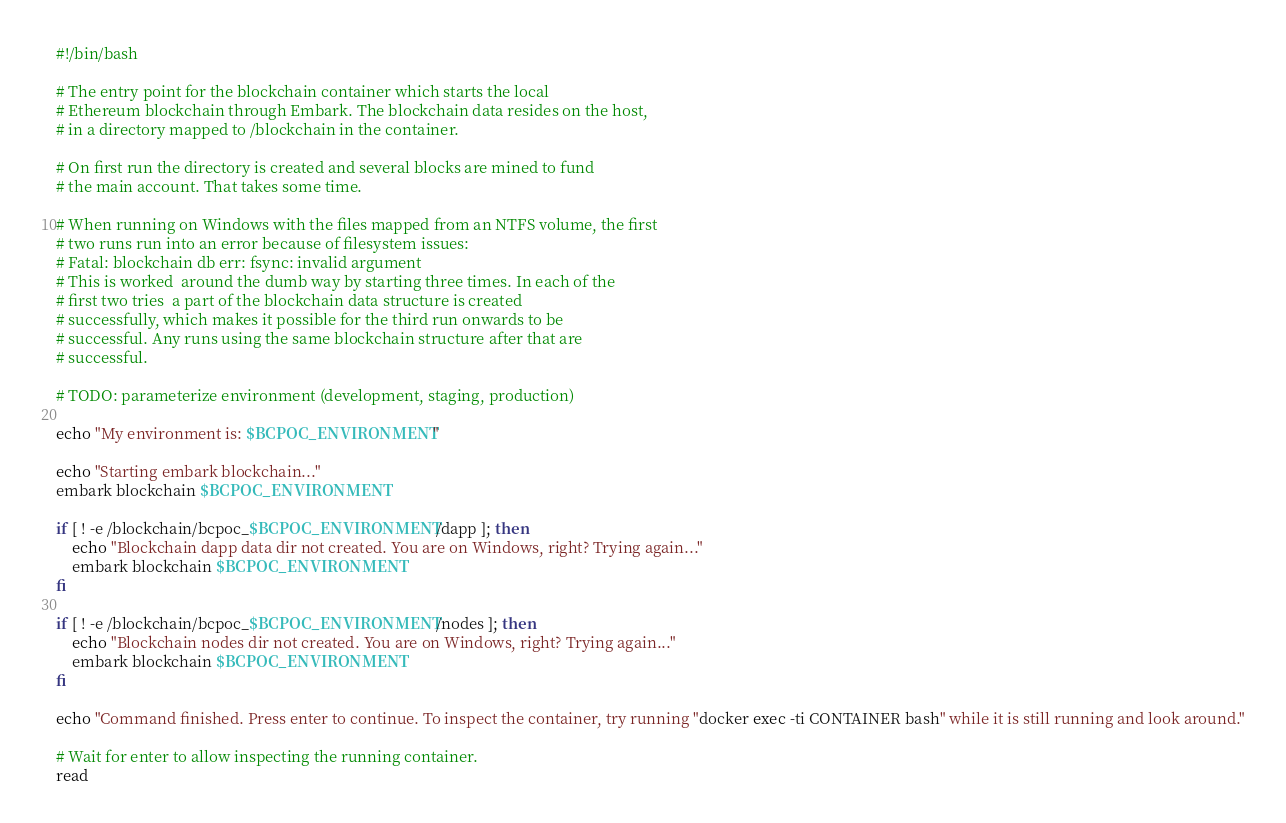Convert code to text. <code><loc_0><loc_0><loc_500><loc_500><_Bash_>#!/bin/bash

# The entry point for the blockchain container which starts the local
# Ethereum blockchain through Embark. The blockchain data resides on the host,
# in a directory mapped to /blockchain in the container.

# On first run the directory is created and several blocks are mined to fund
# the main account. That takes some time.

# When running on Windows with the files mapped from an NTFS volume, the first
# two runs run into an error because of filesystem issues:
# Fatal: blockchain db err: fsync: invalid argument
# This is worked  around the dumb way by starting three times. In each of the
# first two tries  a part of the blockchain data structure is created
# successfully, which makes it possible for the third run onwards to be
# successful. Any runs using the same blockchain structure after that are
# successful.

# TODO: parameterize environment (development, staging, production)

echo "My environment is: $BCPOC_ENVIRONMENT"

echo "Starting embark blockchain..."
embark blockchain $BCPOC_ENVIRONMENT

if [ ! -e /blockchain/bcpoc_$BCPOC_ENVIRONMENT/dapp ]; then
    echo "Blockchain dapp data dir not created. You are on Windows, right? Trying again..."
    embark blockchain $BCPOC_ENVIRONMENT
fi

if [ ! -e /blockchain/bcpoc_$BCPOC_ENVIRONMENT/nodes ]; then
    echo "Blockchain nodes dir not created. You are on Windows, right? Trying again..."
    embark blockchain $BCPOC_ENVIRONMENT
fi

echo "Command finished. Press enter to continue. To inspect the container, try running "docker exec -ti CONTAINER bash" while it is still running and look around."

# Wait for enter to allow inspecting the running container.
read
</code> 